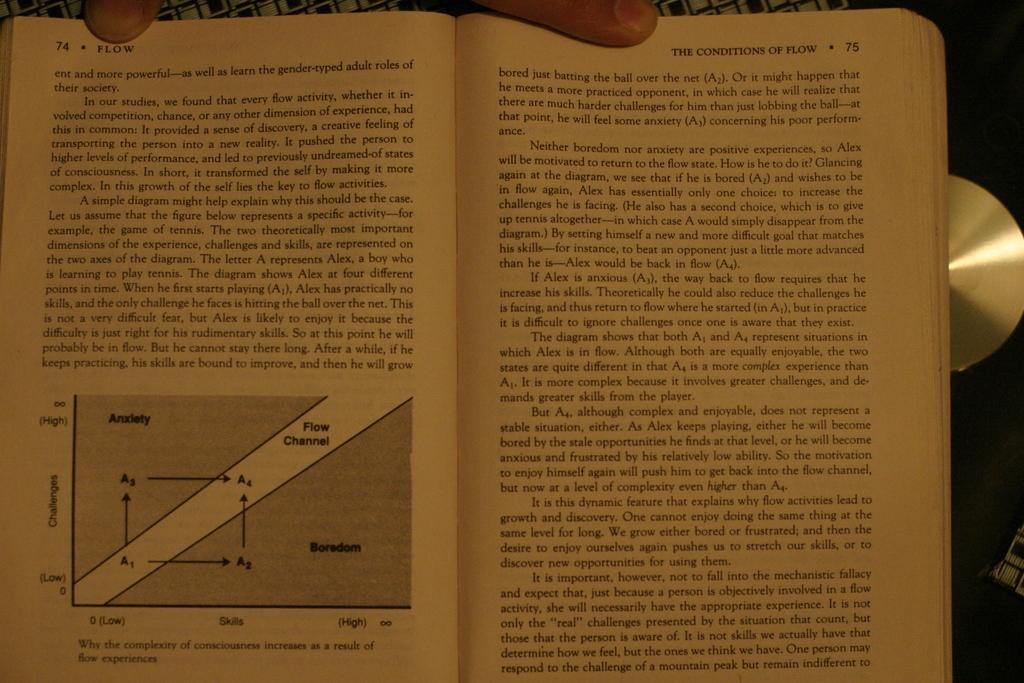What is the title of the graph?
Offer a terse response. Unanswerable. What is a word written on the left page?
Ensure brevity in your answer.  Flow. 